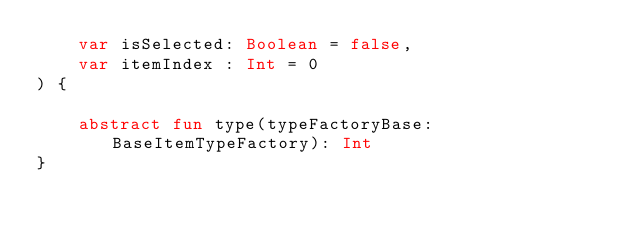<code> <loc_0><loc_0><loc_500><loc_500><_Kotlin_>    var isSelected: Boolean = false,
    var itemIndex : Int = 0
) {

    abstract fun type(typeFactoryBase: BaseItemTypeFactory): Int
}</code> 